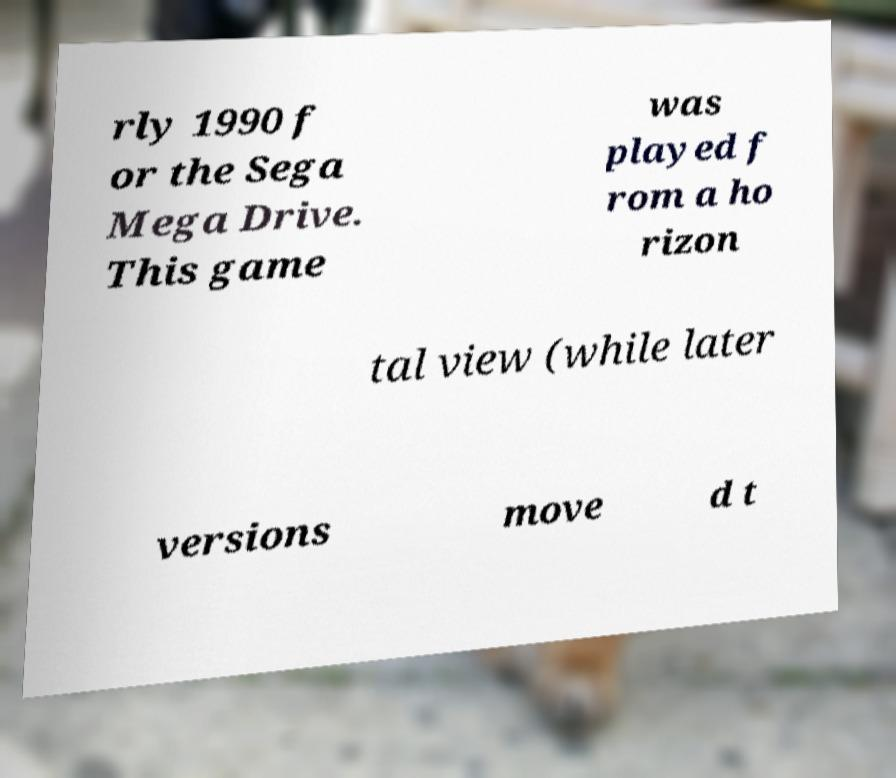Can you accurately transcribe the text from the provided image for me? rly 1990 f or the Sega Mega Drive. This game was played f rom a ho rizon tal view (while later versions move d t 